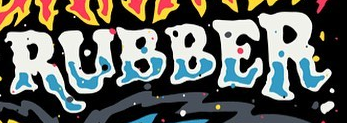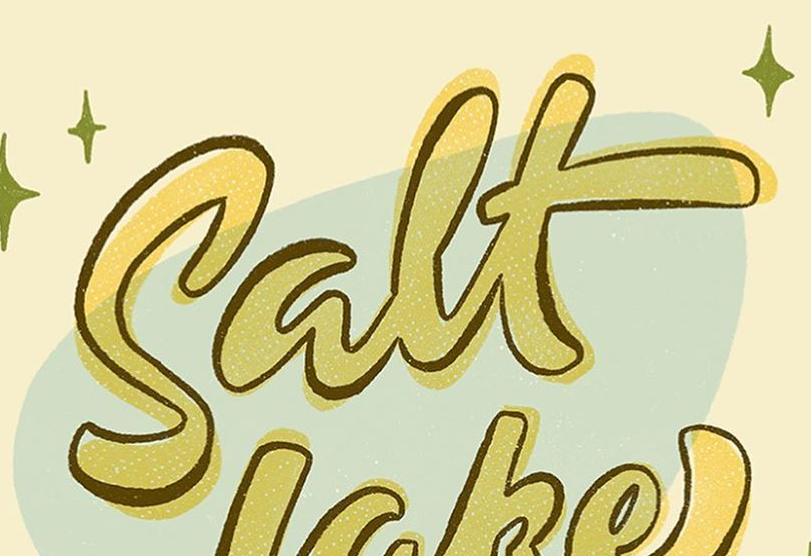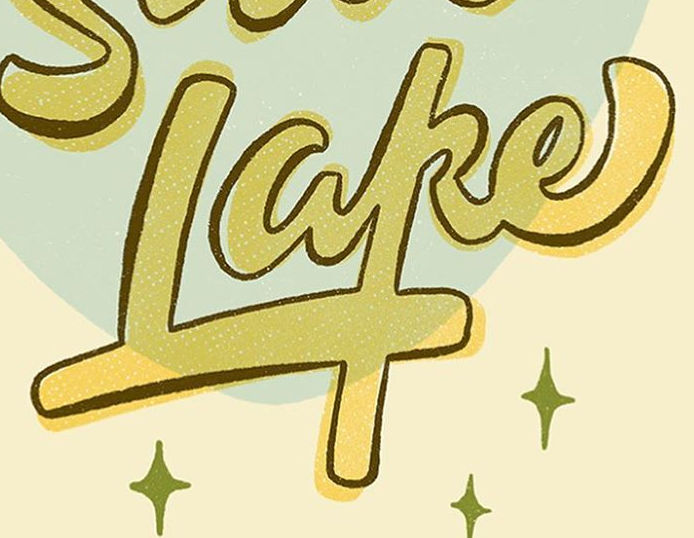What text appears in these images from left to right, separated by a semicolon? RUBBER; Salt; Lake 